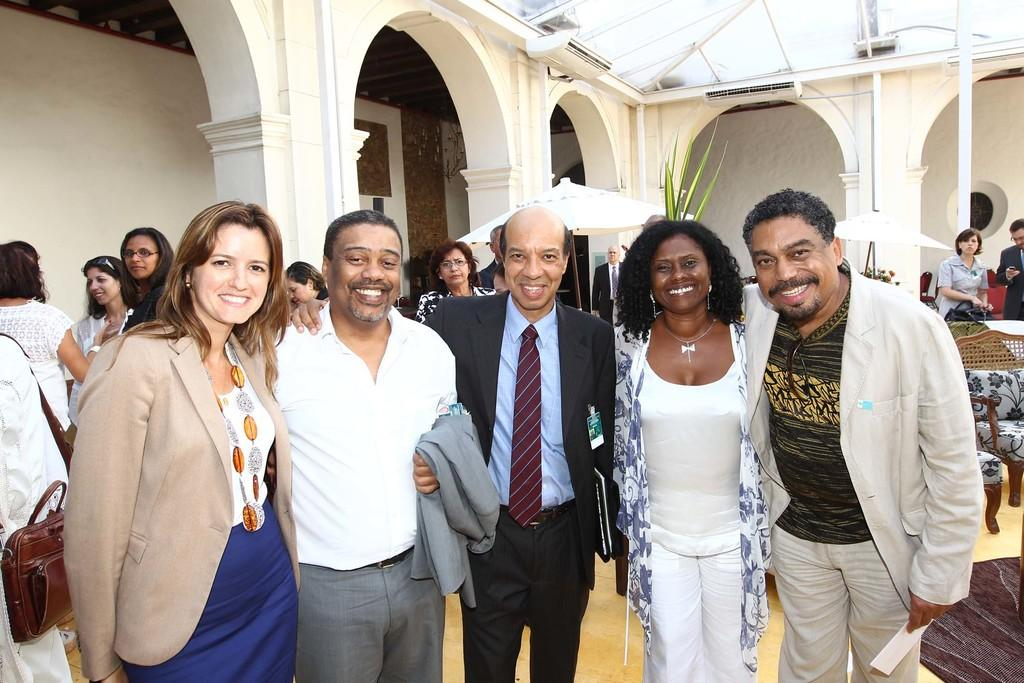What are the people in the image doing? The people in the image are standing and posing for the camera. What is the facial expression of the people in the image? The people in the image are smiling. Are there any other people visible in the image? Yes, there are other people standing behind them. What type of furniture can be seen in the image? There are chairs in the image. What type of salt is being used to season the people in the image? There is no salt present in the image, and the people are not being seasoned. 